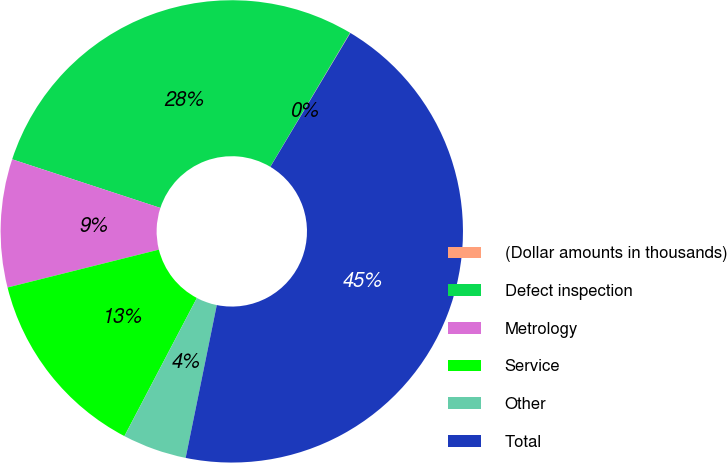<chart> <loc_0><loc_0><loc_500><loc_500><pie_chart><fcel>(Dollar amounts in thousands)<fcel>Defect inspection<fcel>Metrology<fcel>Service<fcel>Other<fcel>Total<nl><fcel>0.03%<fcel>28.5%<fcel>8.95%<fcel>13.41%<fcel>4.49%<fcel>44.63%<nl></chart> 